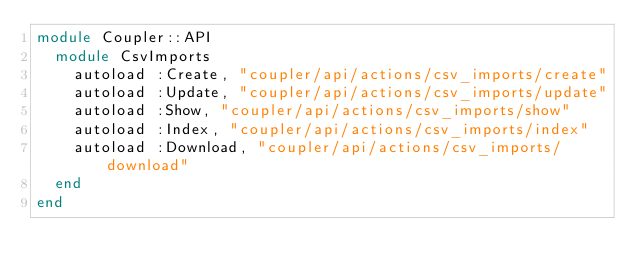<code> <loc_0><loc_0><loc_500><loc_500><_Ruby_>module Coupler::API
  module CsvImports
    autoload :Create, "coupler/api/actions/csv_imports/create"
    autoload :Update, "coupler/api/actions/csv_imports/update"
    autoload :Show, "coupler/api/actions/csv_imports/show"
    autoload :Index, "coupler/api/actions/csv_imports/index"
    autoload :Download, "coupler/api/actions/csv_imports/download"
  end
end
</code> 